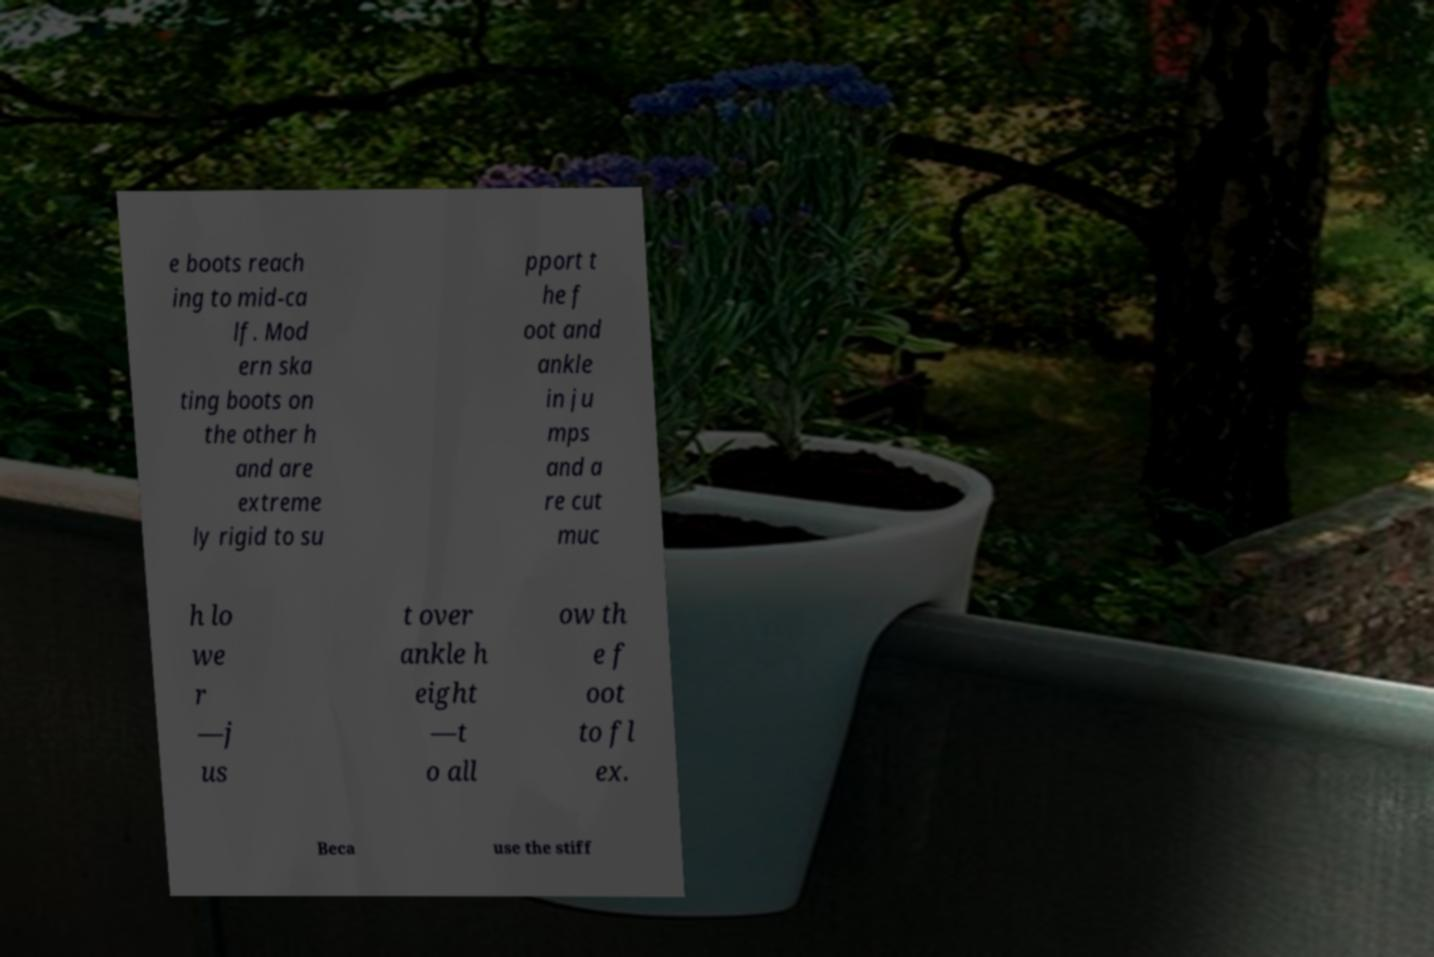There's text embedded in this image that I need extracted. Can you transcribe it verbatim? e boots reach ing to mid-ca lf. Mod ern ska ting boots on the other h and are extreme ly rigid to su pport t he f oot and ankle in ju mps and a re cut muc h lo we r —j us t over ankle h eight —t o all ow th e f oot to fl ex. Beca use the stiff 